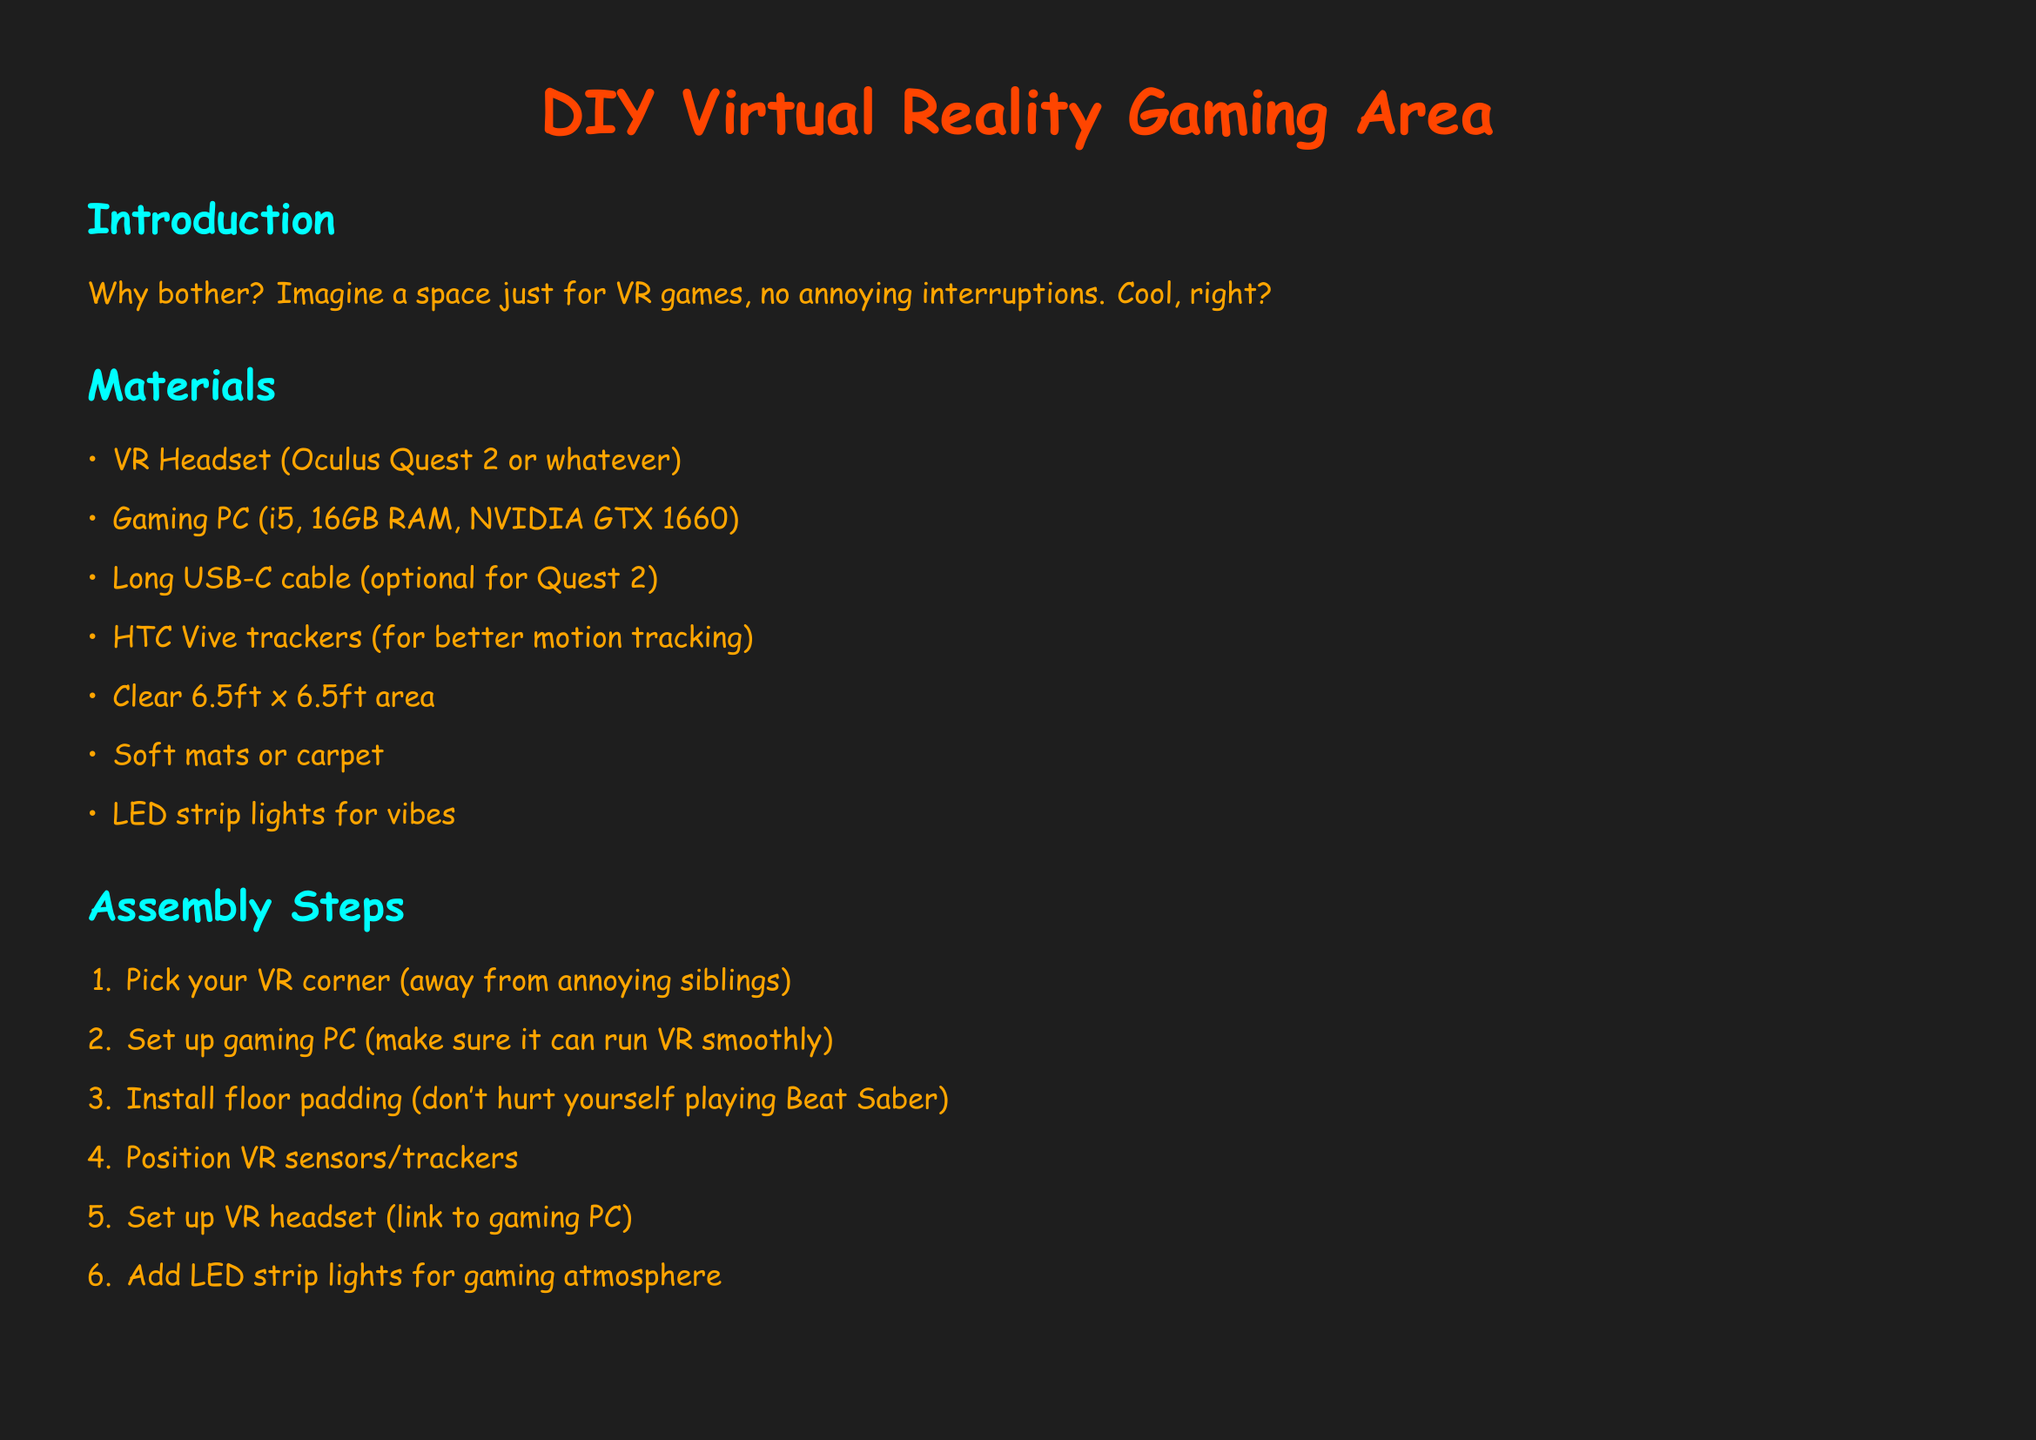What is the title of the document? The title of the document is stated prominently at the beginning, highlighting the main topic of the assembly instructions.
Answer: DIY Virtual Reality Gaming Area How many items are listed in the materials section? The materials section includes an enumerated list of items necessary for setting up the VR gaming area.
Answer: 7 What is the first step in the assembly process? The steps for assembly are provided in a numbered format, starting with a specific action to take to begin setting up the VR area.
Answer: Pick your VR corner What is the minimum area required for the setup? The materials section specifies the required dimensions for the space needed to construct the VR gaming area.
Answer: 6.5ft x 6.5ft What must be cleared for safety? The safety tips list mentions specific items or hazards that should be addressed to ensure a safe VR gaming experience.
Answer: Sharp objects and furniture How should the VR headset be connected? The assembly steps describe how to link the VR headset to the gaming PC to prepare for gaming.
Answer: Link to gaming PC What type of lighting is suggested for the atmosphere? In the materials section, a recommendation is made regarding the type of lighting to enhance the gaming experience.
Answer: LED strip lights What should be worn to prevent dropping controllers? The safety tips include a precaution regarding controller usage during gameplay to avoid accidents.
Answer: Wrist straps How many RAM is suggested for the gaming PC? The materials section specifies the minimum RAM required for the gaming PC to ensure proper functionality during VR gaming.
Answer: 16GB 